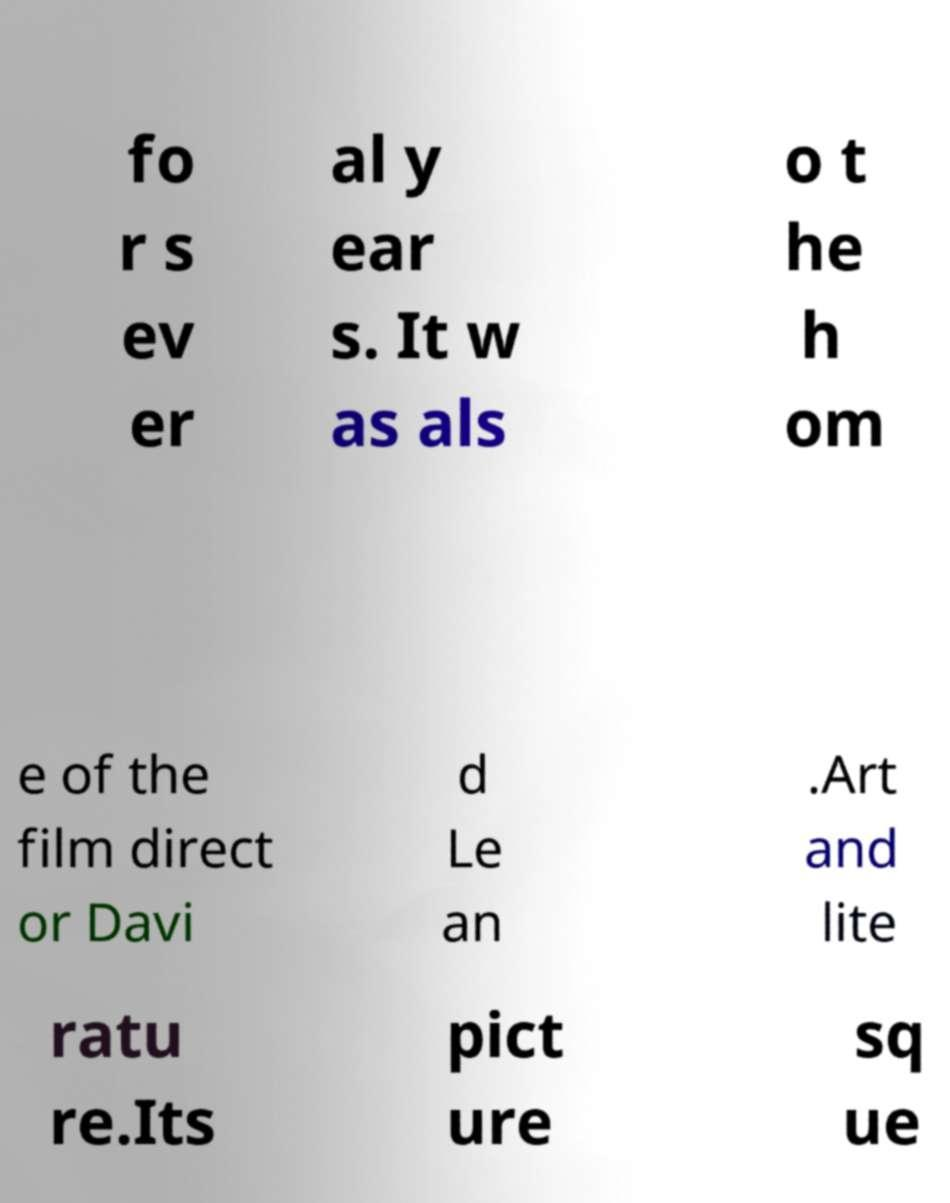There's text embedded in this image that I need extracted. Can you transcribe it verbatim? fo r s ev er al y ear s. It w as als o t he h om e of the film direct or Davi d Le an .Art and lite ratu re.Its pict ure sq ue 